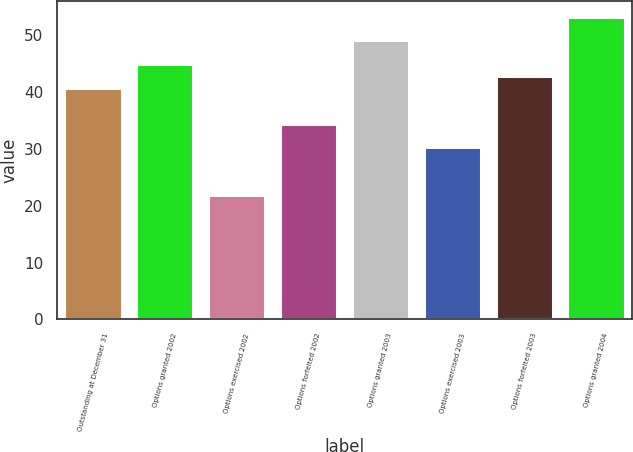<chart> <loc_0><loc_0><loc_500><loc_500><bar_chart><fcel>Outstanding at December 31<fcel>Options granted 2002<fcel>Options exercised 2002<fcel>Options forfeited 2002<fcel>Options granted 2003<fcel>Options exercised 2003<fcel>Options forfeited 2003<fcel>Options granted 2004<nl><fcel>40.73<fcel>44.91<fcel>21.92<fcel>34.46<fcel>49.09<fcel>30.28<fcel>42.82<fcel>53.27<nl></chart> 